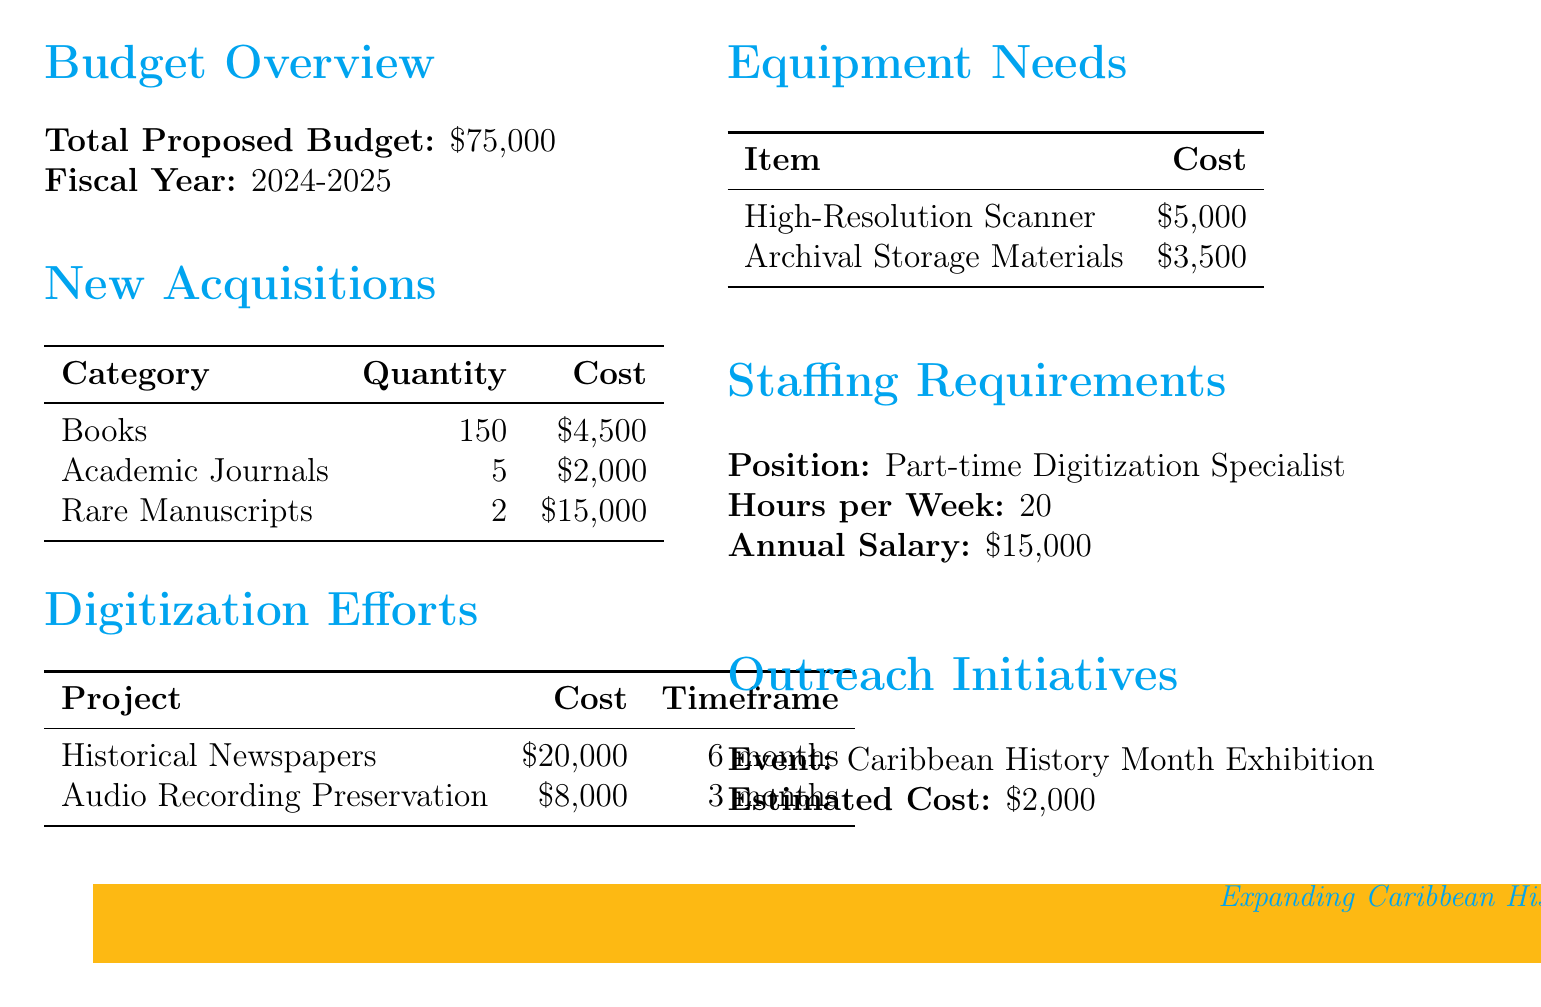what is the total proposed budget? The total proposed budget is stated at the beginning of the document, which is $75,000.
Answer: $75,000 what is the fiscal year for the budget proposal? The fiscal year for the budget proposal is indicated as 2024-2025.
Answer: 2024-2025 how many books are planned for acquisition? The number of books planned for acquisition is provided in the new acquisitions section, which lists 150 books.
Answer: 150 what is the estimated cost for scanning historical newspapers? The estimated cost for the scanning project is provided in the digitization efforts section as $20,000.
Answer: $20,000 how much will the part-time digitization specialist be paid annually? The annual salary for the part-time digitization specialist is given in the staffing requirements section, which is $15,000.
Answer: $15,000 how many rare manuscripts will be acquired? The document specifies that 2 rare manuscripts will be acquired as part of the new acquisitions.
Answer: 2 what is the total estimated cost for digitization efforts? The total estimated cost for digitization efforts is calculated by adding the costs of both projects: $20,000 + $8,000 = $28,000.
Answer: $28,000 how many hours per week will the part-time specialist work? The document states the part-time digitization specialist will work 20 hours per week.
Answer: 20 what is the cost for the Caribbean History Month exhibition? The cost for the Caribbean History Month exhibition is outlined in the outreach initiatives section as $2,000.
Answer: $2,000 